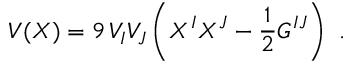<formula> <loc_0><loc_0><loc_500><loc_500>V ( X ) = 9 \, V _ { I } V _ { J } \left ( X ^ { I } X ^ { J } - { \frac { 1 } { 2 } } G ^ { I J } \right ) \ .</formula> 